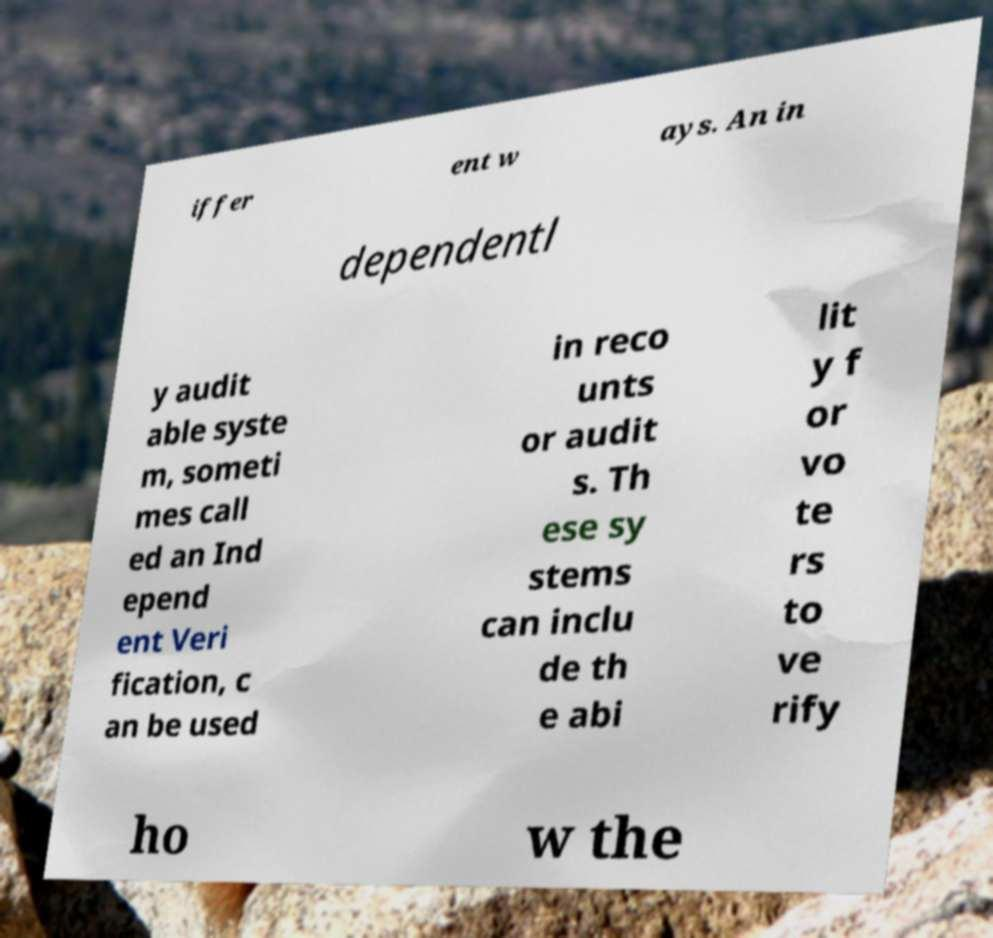I need the written content from this picture converted into text. Can you do that? iffer ent w ays. An in dependentl y audit able syste m, someti mes call ed an Ind epend ent Veri fication, c an be used in reco unts or audit s. Th ese sy stems can inclu de th e abi lit y f or vo te rs to ve rify ho w the 